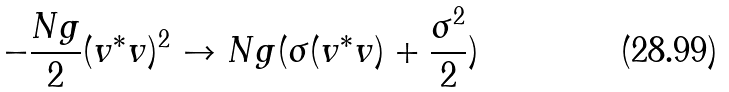Convert formula to latex. <formula><loc_0><loc_0><loc_500><loc_500>- \frac { N g } { 2 } ( v ^ { * } v ) ^ { 2 } \to N g ( \sigma ( v ^ { * } v ) + \frac { \sigma ^ { 2 } } { 2 } )</formula> 